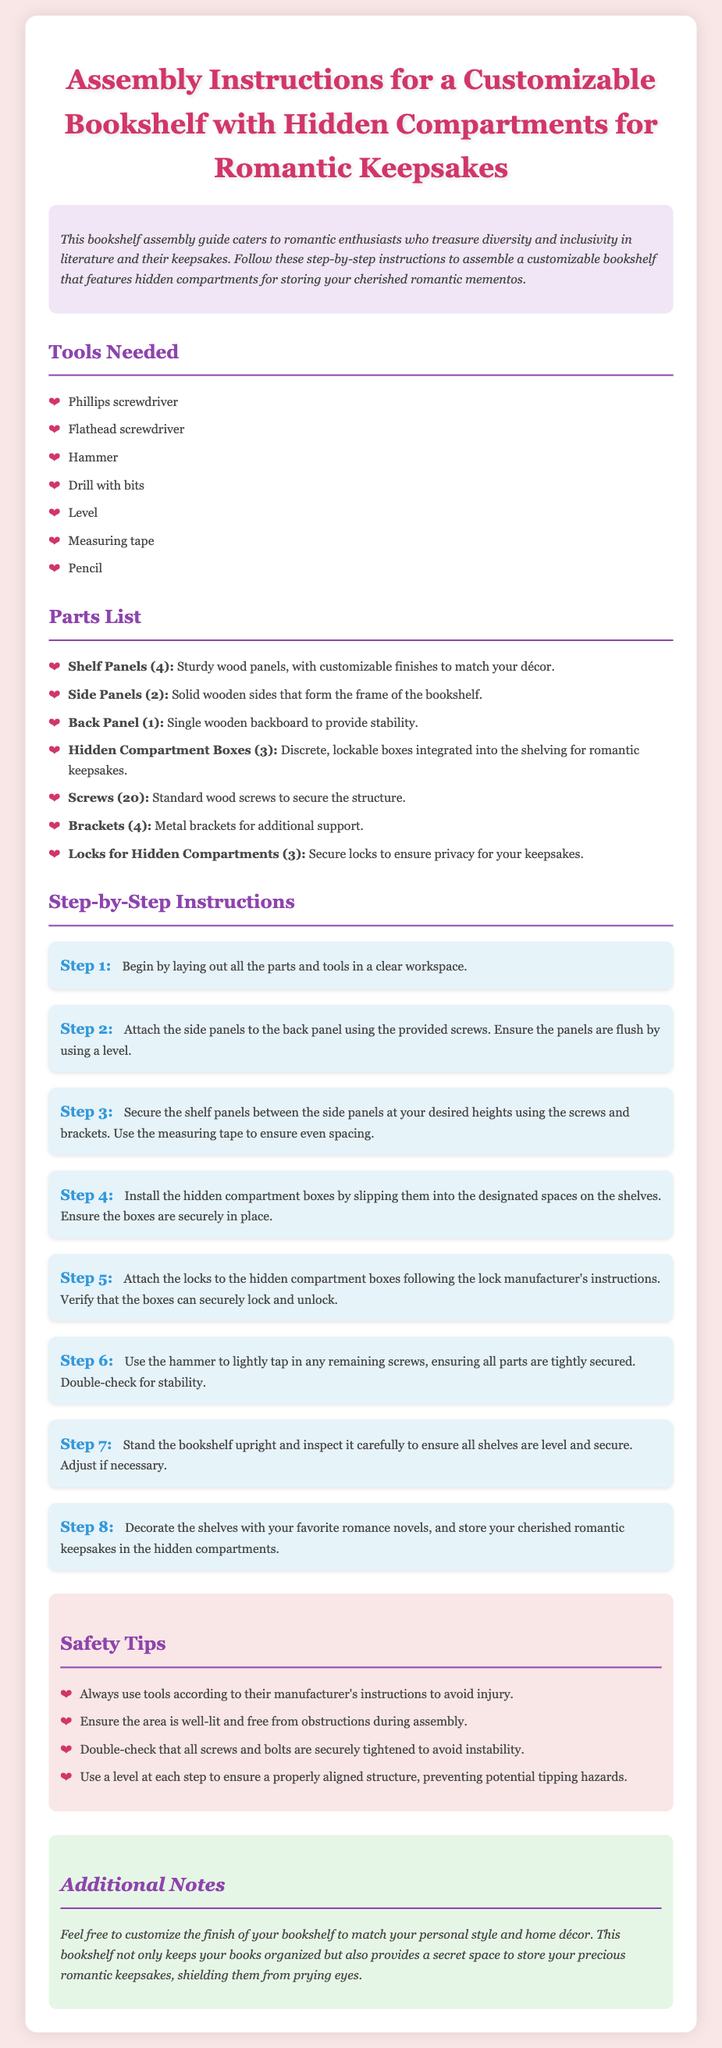what is the title of the document? The title is provided in the header section of the document, stating the specific assembly instructions.
Answer: Assembly Instructions for a Customizable Bookshelf with Hidden Compartments for Romantic Keepsakes how many hidden compartment boxes are included? The parts list specifies the number of hidden compartment boxes clearly.
Answer: 3 what tool is needed for securing screws? The document lists required tools, including one specifically used for screws.
Answer: Phillips screwdriver what is the first step in the assembly process? The step-by-step instructions detail the order of assembly steps.
Answer: Begin by laying out all the parts and tools in a clear workspace which color is emphasized throughout the document? The document includes stylistic elements that highlight a particular color, indicating romance.
Answer: pink what should you use to ensure the shelves are level? The assembly instructions advise a specific tool for checking levels during setup.
Answer: level how many screws are required for assembly? The parts list provides a specific quantity of screws necessary for the construction.
Answer: 20 what is suggested for storing romantic keepsakes? The steps related to storage provide insight into the intended purpose of specific compartments.
Answer: hidden compartments 